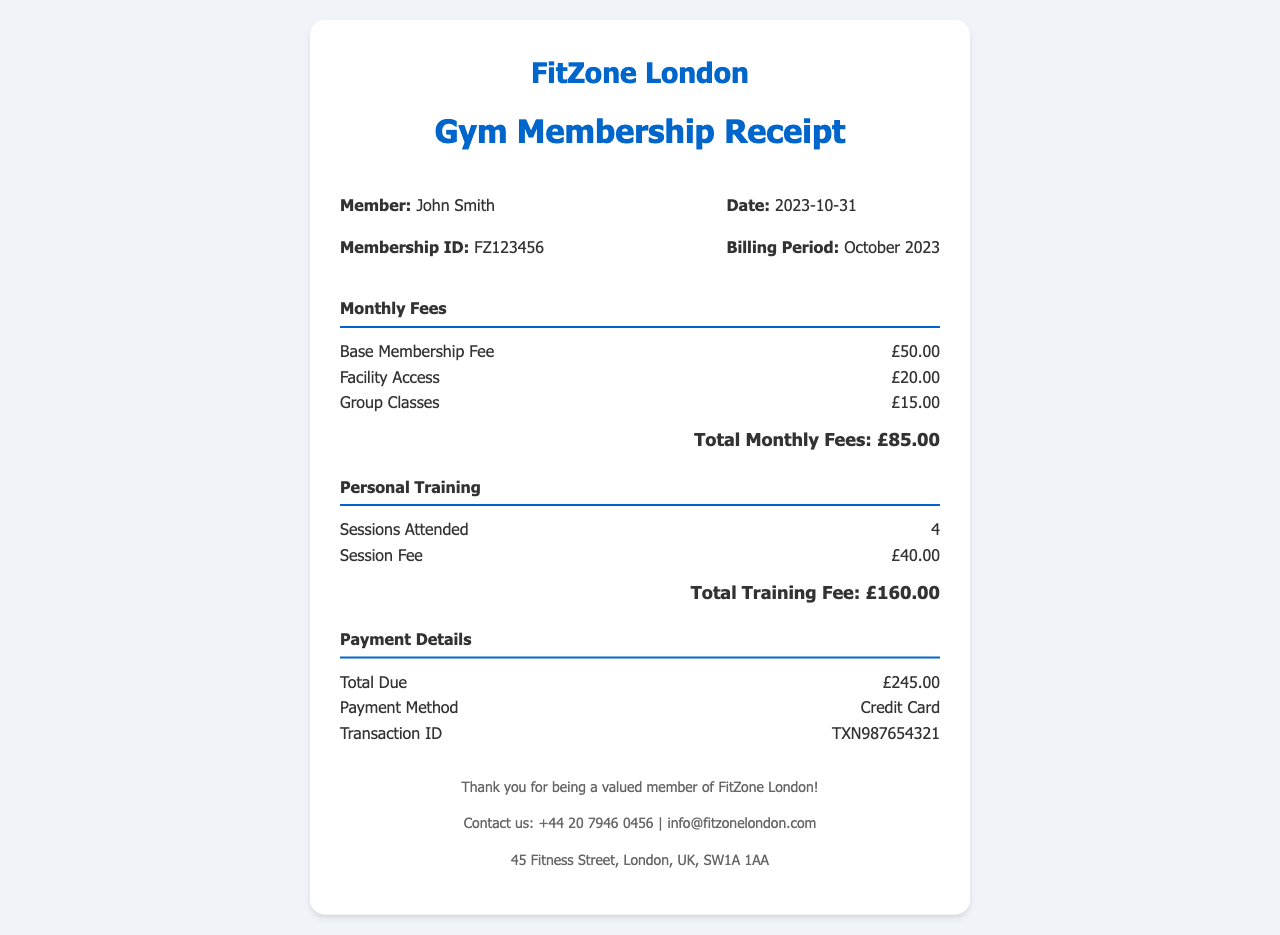What is the member's name? The member's name is displayed at the top of the receipt.
Answer: John Smith What is the total monthly fees? The total monthly fees are calculated by adding the base membership fee, facility access, and group classes fees.
Answer: £85.00 How many personal training sessions were attended? The number of sessions attended is listed in the personal training section of the receipt.
Answer: 4 What is the session fee for personal training? The session fee is specified in the personal training section.
Answer: £40.00 What is the total due amount? The total due amount is the sum of total monthly fees and total training fee listed in the payment details.
Answer: £245.00 What is the payment method used? The payment method is provided in the payment details section of the receipt.
Answer: Credit Card What is the membership ID? The membership ID is assigned to the member and displayed in the receipt details.
Answer: FZ123456 What is the date of the receipt? The date of the receipt indicates when the billing period ends, which is specified on the document.
Answer: 2023-10-31 What is the fee for facility access? The fee for facility access is included in the monthly fees section.
Answer: £20.00 